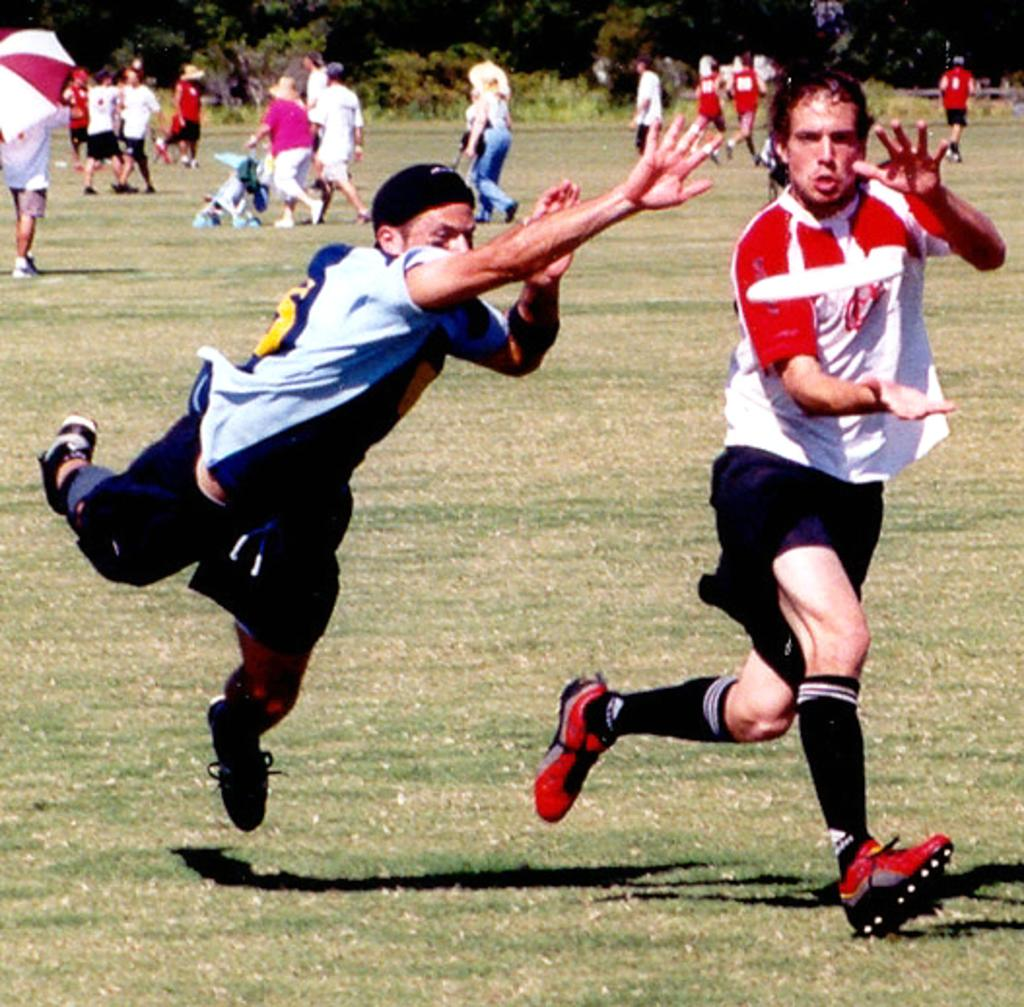Who or what can be seen in the image? There are people in the image. What type of natural environment is visible in the image? There is grass visible in the image. What object is present for transporting a child? There is a stroller in the image. What is used for shade in the image? There is an umbrella in the image. What can be seen in the distance in the image? There are trees in the background of the image. What type of volcano can be seen erupting in the background of the image? There is no volcano present in the image; it features people, grass, a stroller, an umbrella, and trees. What value is assigned to the bells in the image? There are no bells present in the image, so it is not possible to assign a value to them. 